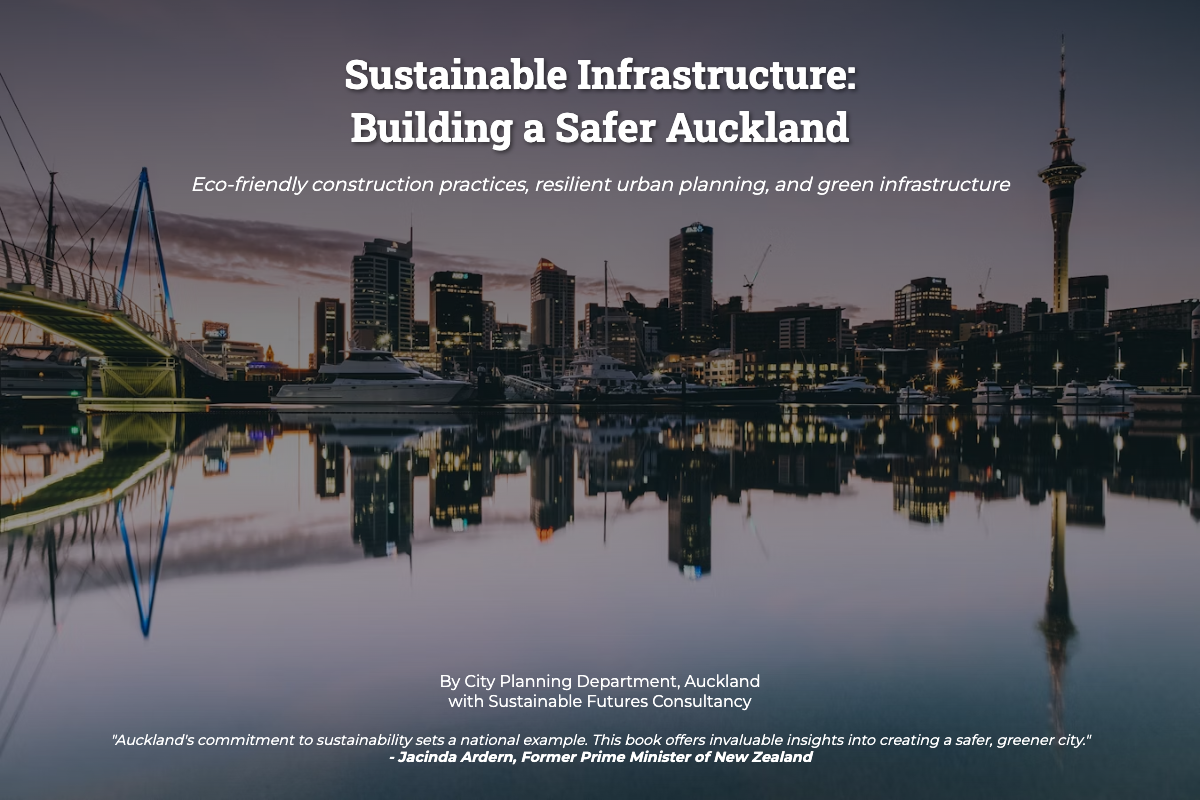What is the title of the book? The title is prominently displayed at the top of the cover, identifying the subject matter of the book on sustainable infrastructure.
Answer: Sustainable Infrastructure: Building a Safer Auckland Who are the authors of the book? The authorship is attributed to both the City Planning Department and an associated consultancy, indicating collaboration on the project.
Answer: City Planning Department, Auckland with Sustainable Futures Consultancy What visual elements are featured on the cover? The cover includes icons representing green rooftops, solar panels, and wind turbines, which visually communicate the themes of sustainability and eco-friendliness.
Answer: Green rooftops, solar panels, wind turbines Who endorsed the book? The endorsement section prominently features a notable figure from New Zealand's political landscape, lending credibility and perspective on the book's content.
Answer: Jacinda Ardern What message does the endorsement convey? The endorsement reflects a commitment to sustainability and highlights the book’s potential impact on urban planning, demonstrating its relevance to broader societal goals.
Answer: Auckland's commitment to sustainability sets a national example What themes are highlighted in the subtitle? The subtitle provides insights into the core topics covered in the book, focusing on environmentally friendly practices in infrastructure development and urban management.
Answer: Eco-friendly construction practices, resilient urban planning, and green infrastructure How does the cover visually represent sustainability? The use of design elements like green rooftops, solar panels, and wind turbines illustrates a commitment to environmentally sustainable practices in urban design.
Answer: Eco-friendly construction practices What is the color scheme of the cover? The cover employs a gradient overlay on a background image, which enhances visibility of the text and aligns with the eco-friendly theme.
Answer: Light blue and dark gradient 